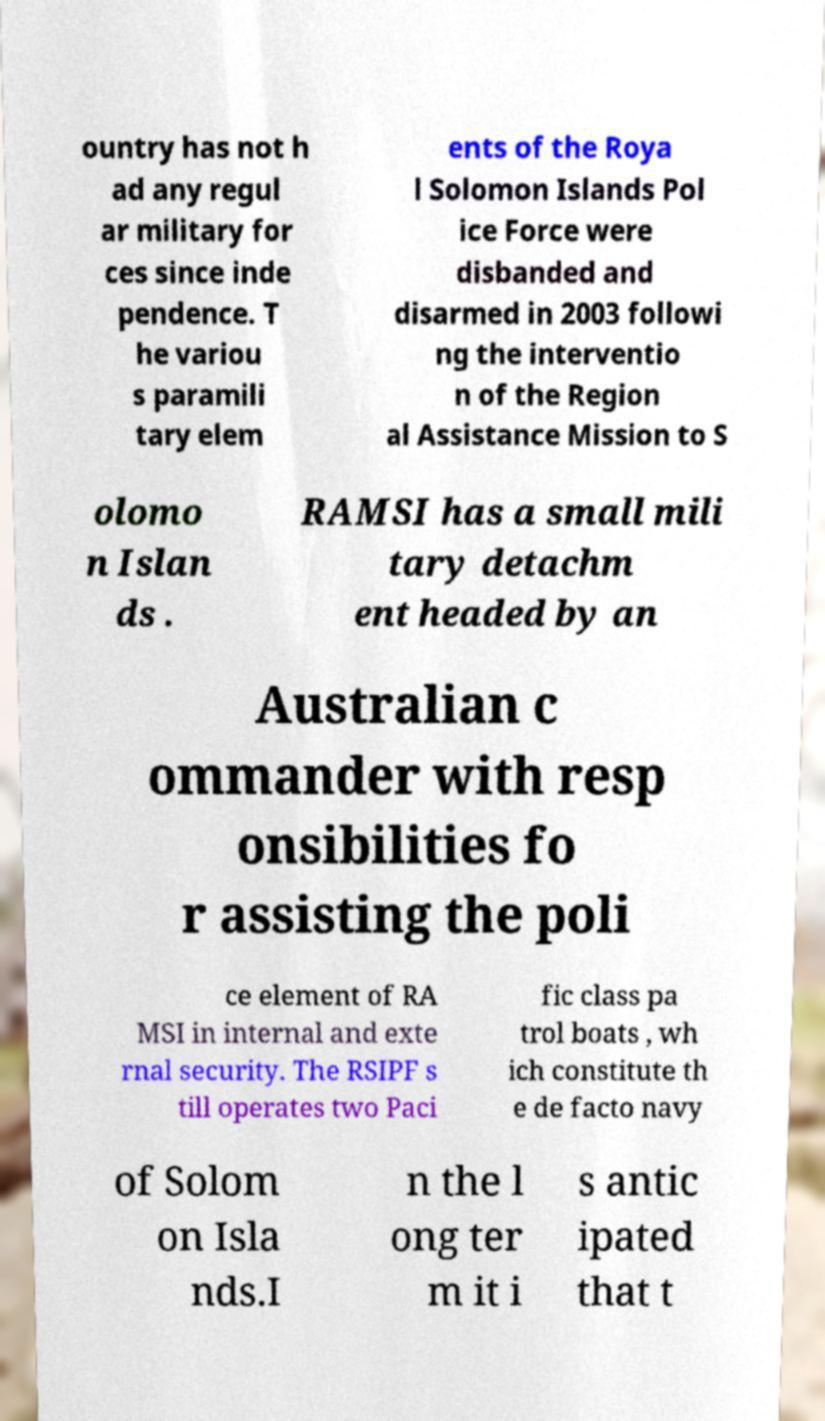Can you read and provide the text displayed in the image?This photo seems to have some interesting text. Can you extract and type it out for me? ountry has not h ad any regul ar military for ces since inde pendence. T he variou s paramili tary elem ents of the Roya l Solomon Islands Pol ice Force were disbanded and disarmed in 2003 followi ng the interventio n of the Region al Assistance Mission to S olomo n Islan ds . RAMSI has a small mili tary detachm ent headed by an Australian c ommander with resp onsibilities fo r assisting the poli ce element of RA MSI in internal and exte rnal security. The RSIPF s till operates two Paci fic class pa trol boats , wh ich constitute th e de facto navy of Solom on Isla nds.I n the l ong ter m it i s antic ipated that t 